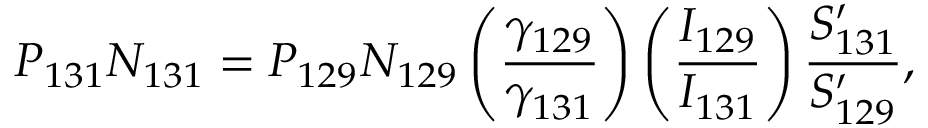Convert formula to latex. <formula><loc_0><loc_0><loc_500><loc_500>P _ { 1 3 1 } N _ { 1 3 1 } = P _ { 1 2 9 } N _ { 1 2 9 } \left ( { \frac { \gamma _ { 1 2 9 } } { \gamma _ { 1 3 1 } } } \right ) \left ( { \frac { I _ { 1 2 9 } } { I _ { 1 3 1 } } } \right ) { \frac { S _ { 1 3 1 } ^ { \prime } } { S _ { 1 2 9 } ^ { \prime } } } ,</formula> 